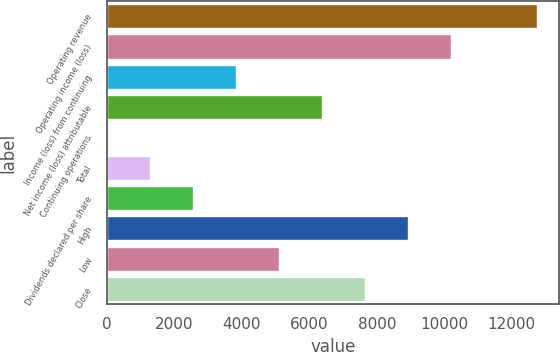Convert chart. <chart><loc_0><loc_0><loc_500><loc_500><bar_chart><fcel>Operating revenue<fcel>Operating income (loss)<fcel>Income (loss) from continuing<fcel>Net income (loss) attributable<fcel>Continuing operations<fcel>Total<fcel>Dividends declared per share<fcel>High<fcel>Low<fcel>Close<nl><fcel>12760<fcel>10208<fcel>3828.07<fcel>6380.05<fcel>0.1<fcel>1276.09<fcel>2552.08<fcel>8932.03<fcel>5104.06<fcel>7656.04<nl></chart> 